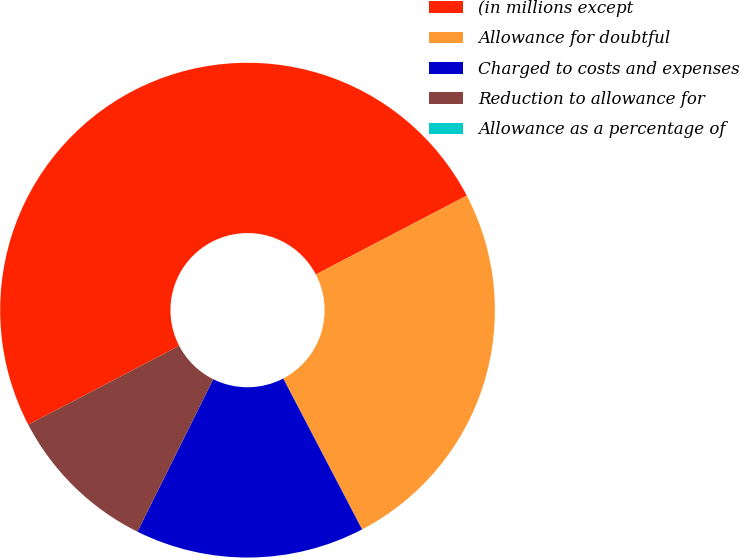Convert chart to OTSL. <chart><loc_0><loc_0><loc_500><loc_500><pie_chart><fcel>(in millions except<fcel>Allowance for doubtful<fcel>Charged to costs and expenses<fcel>Reduction to allowance for<fcel>Allowance as a percentage of<nl><fcel>50.0%<fcel>25.0%<fcel>15.0%<fcel>10.0%<fcel>0.0%<nl></chart> 